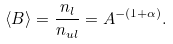Convert formula to latex. <formula><loc_0><loc_0><loc_500><loc_500>\langle B \rangle = \frac { n _ { l } } { n _ { u l } } = A ^ { - ( 1 + \alpha ) } .</formula> 